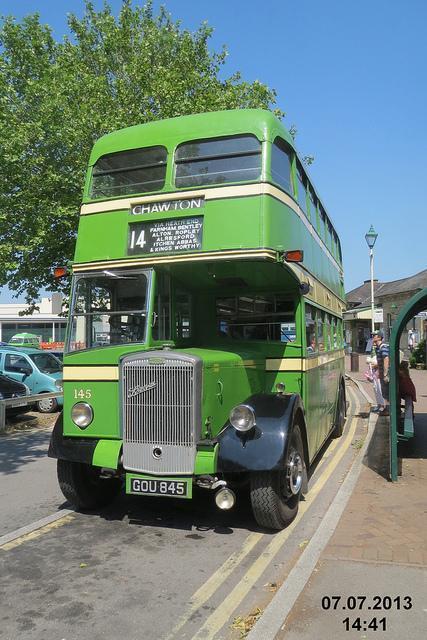In which country does this bus travel?
Select the accurate answer and provide explanation: 'Answer: answer
Rationale: rationale.'
Options: United states, belize, chile, great britain. Answer: great britain.
Rationale: The country is in britain. 